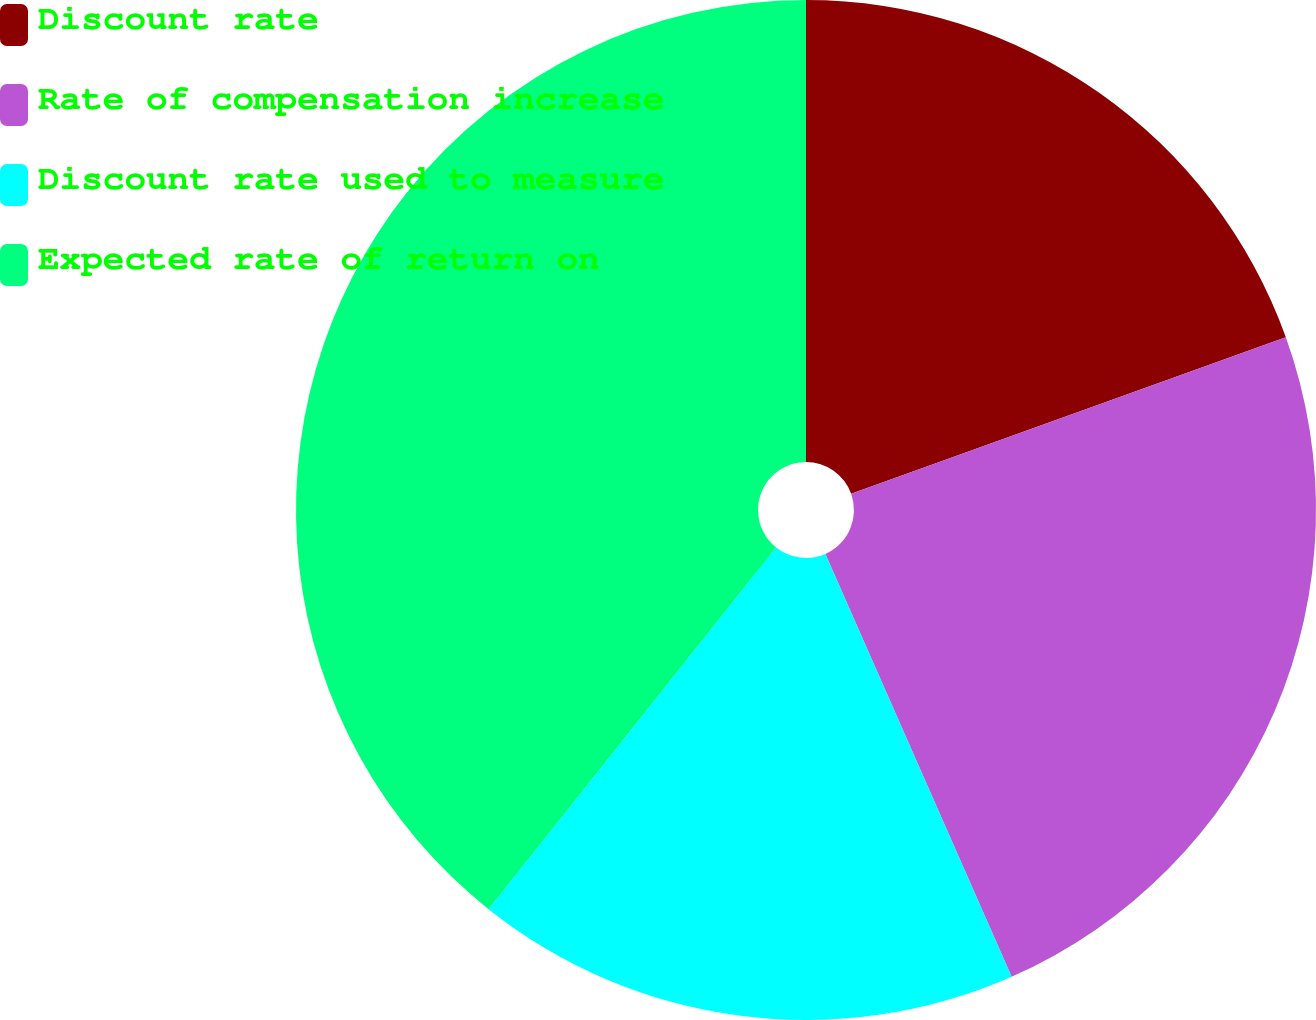Convert chart to OTSL. <chart><loc_0><loc_0><loc_500><loc_500><pie_chart><fcel>Discount rate<fcel>Rate of compensation increase<fcel>Discount rate used to measure<fcel>Expected rate of return on<nl><fcel>19.5%<fcel>23.9%<fcel>17.3%<fcel>39.31%<nl></chart> 